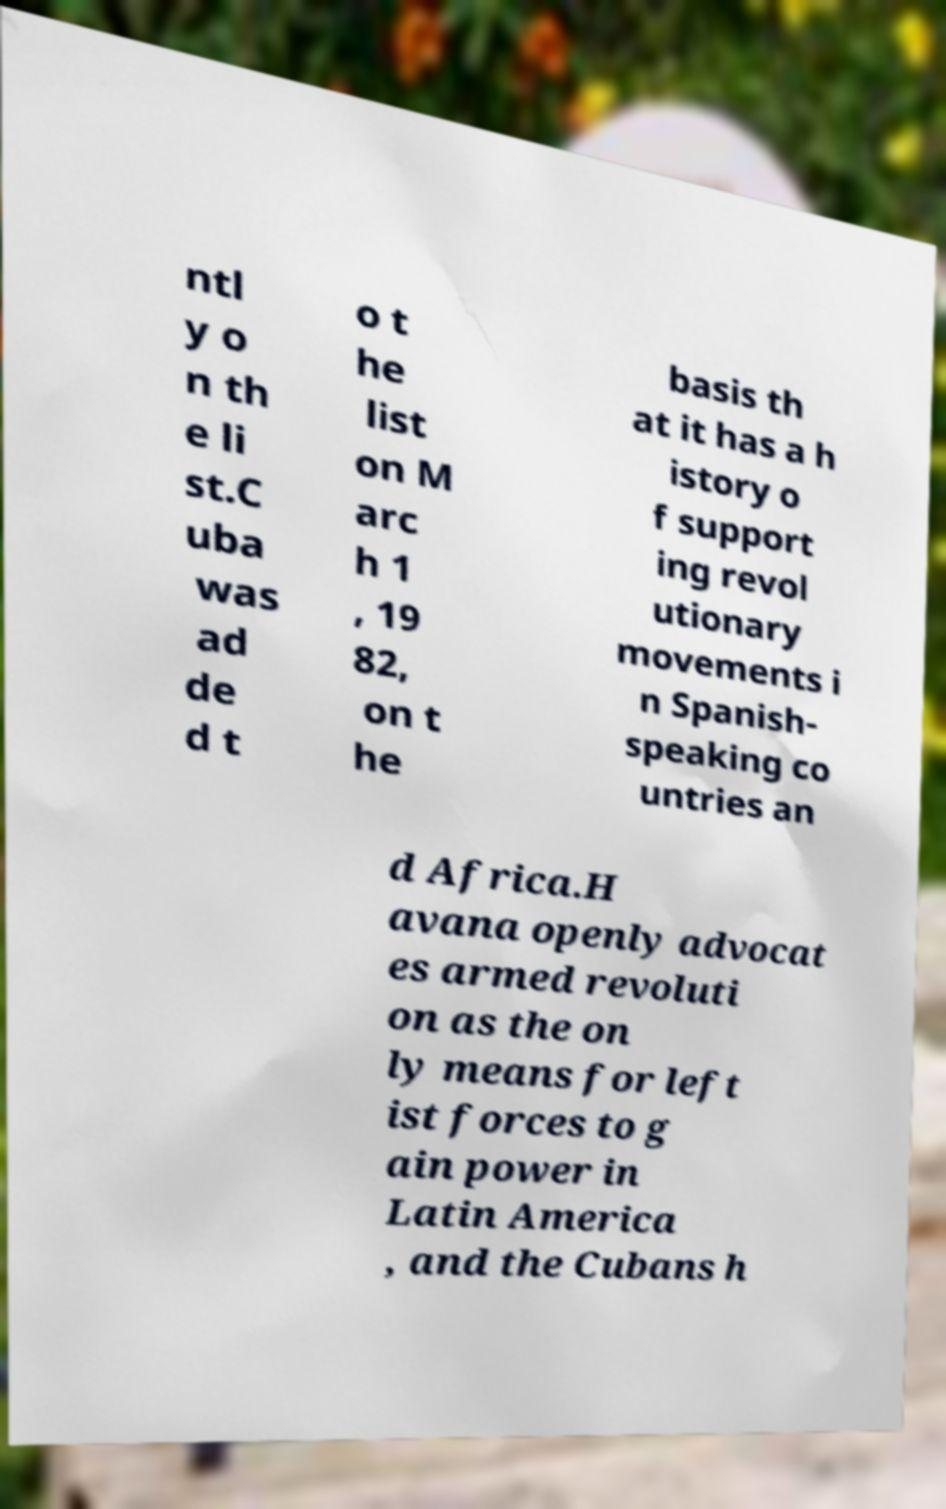Can you read and provide the text displayed in the image?This photo seems to have some interesting text. Can you extract and type it out for me? ntl y o n th e li st.C uba was ad de d t o t he list on M arc h 1 , 19 82, on t he basis th at it has a h istory o f support ing revol utionary movements i n Spanish- speaking co untries an d Africa.H avana openly advocat es armed revoluti on as the on ly means for left ist forces to g ain power in Latin America , and the Cubans h 